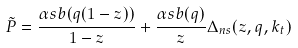<formula> <loc_0><loc_0><loc_500><loc_500>\tilde { P } = \frac { \alpha s b ( q ( 1 - z ) ) } { 1 - z } + \frac { \alpha s b ( q ) } { z } \Delta _ { n s } ( z , q , k _ { t } )</formula> 